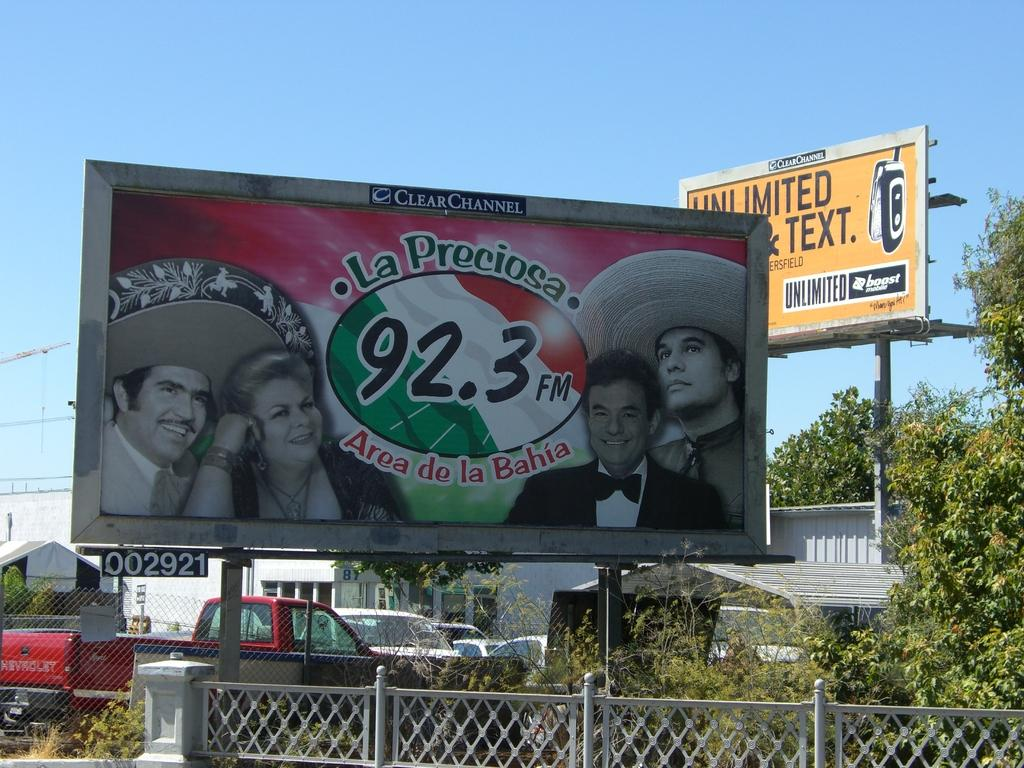<image>
Create a compact narrative representing the image presented. A billboard above a chain link fence advertises La Preciosa, 92.3 FM, Area de la Baja and has a picture of 4 people, 2 of which are wearing sombreros. 